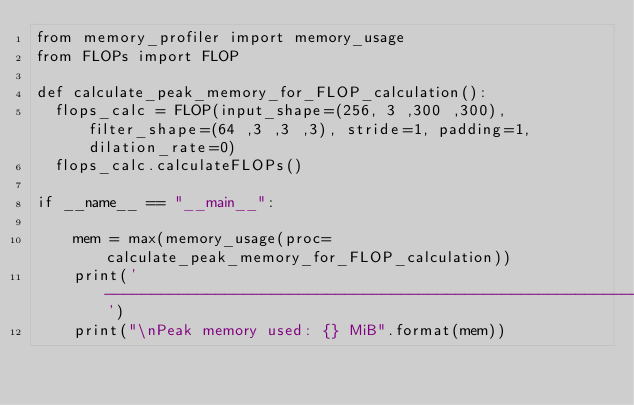Convert code to text. <code><loc_0><loc_0><loc_500><loc_500><_Python_>from memory_profiler import memory_usage
from FLOPs import FLOP

def calculate_peak_memory_for_FLOP_calculation():
  flops_calc = FLOP(input_shape=(256, 3 ,300 ,300), filter_shape=(64 ,3 ,3 ,3), stride=1, padding=1, dilation_rate=0)
  flops_calc.calculateFLOPs()

if __name__ == "__main__":
    
    mem = max(memory_usage(proc=calculate_peak_memory_for_FLOP_calculation))
    print('-----------------------------------------------------------------')
    print("\nPeak memory used: {} MiB".format(mem))</code> 